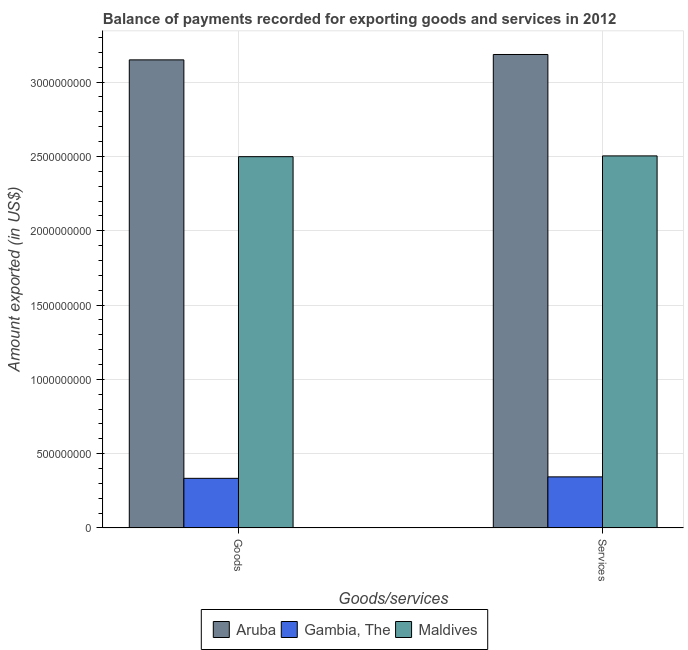How many groups of bars are there?
Ensure brevity in your answer.  2. Are the number of bars per tick equal to the number of legend labels?
Ensure brevity in your answer.  Yes. How many bars are there on the 2nd tick from the left?
Give a very brief answer. 3. How many bars are there on the 1st tick from the right?
Make the answer very short. 3. What is the label of the 1st group of bars from the left?
Provide a succinct answer. Goods. What is the amount of goods exported in Maldives?
Your response must be concise. 2.50e+09. Across all countries, what is the maximum amount of services exported?
Ensure brevity in your answer.  3.19e+09. Across all countries, what is the minimum amount of goods exported?
Your response must be concise. 3.34e+08. In which country was the amount of services exported maximum?
Give a very brief answer. Aruba. In which country was the amount of goods exported minimum?
Your response must be concise. Gambia, The. What is the total amount of goods exported in the graph?
Make the answer very short. 5.98e+09. What is the difference between the amount of goods exported in Maldives and that in Aruba?
Provide a succinct answer. -6.51e+08. What is the difference between the amount of services exported in Gambia, The and the amount of goods exported in Maldives?
Provide a succinct answer. -2.15e+09. What is the average amount of goods exported per country?
Your response must be concise. 1.99e+09. What is the difference between the amount of goods exported and amount of services exported in Aruba?
Provide a short and direct response. -3.61e+07. In how many countries, is the amount of services exported greater than 2400000000 US$?
Provide a succinct answer. 2. What is the ratio of the amount of goods exported in Aruba to that in Gambia, The?
Ensure brevity in your answer.  9.43. Is the amount of goods exported in Maldives less than that in Gambia, The?
Your response must be concise. No. In how many countries, is the amount of services exported greater than the average amount of services exported taken over all countries?
Make the answer very short. 2. What does the 1st bar from the left in Services represents?
Give a very brief answer. Aruba. What does the 2nd bar from the right in Services represents?
Your response must be concise. Gambia, The. How many bars are there?
Give a very brief answer. 6. What is the difference between two consecutive major ticks on the Y-axis?
Make the answer very short. 5.00e+08. Are the values on the major ticks of Y-axis written in scientific E-notation?
Your answer should be very brief. No. Does the graph contain any zero values?
Provide a short and direct response. No. How many legend labels are there?
Offer a very short reply. 3. What is the title of the graph?
Give a very brief answer. Balance of payments recorded for exporting goods and services in 2012. Does "Dominican Republic" appear as one of the legend labels in the graph?
Your answer should be very brief. No. What is the label or title of the X-axis?
Provide a short and direct response. Goods/services. What is the label or title of the Y-axis?
Your answer should be very brief. Amount exported (in US$). What is the Amount exported (in US$) in Aruba in Goods?
Give a very brief answer. 3.15e+09. What is the Amount exported (in US$) of Gambia, The in Goods?
Provide a succinct answer. 3.34e+08. What is the Amount exported (in US$) in Maldives in Goods?
Provide a succinct answer. 2.50e+09. What is the Amount exported (in US$) in Aruba in Services?
Offer a very short reply. 3.19e+09. What is the Amount exported (in US$) of Gambia, The in Services?
Make the answer very short. 3.44e+08. What is the Amount exported (in US$) in Maldives in Services?
Provide a succinct answer. 2.50e+09. Across all Goods/services, what is the maximum Amount exported (in US$) in Aruba?
Ensure brevity in your answer.  3.19e+09. Across all Goods/services, what is the maximum Amount exported (in US$) in Gambia, The?
Offer a terse response. 3.44e+08. Across all Goods/services, what is the maximum Amount exported (in US$) in Maldives?
Your response must be concise. 2.50e+09. Across all Goods/services, what is the minimum Amount exported (in US$) in Aruba?
Your response must be concise. 3.15e+09. Across all Goods/services, what is the minimum Amount exported (in US$) in Gambia, The?
Provide a succinct answer. 3.34e+08. Across all Goods/services, what is the minimum Amount exported (in US$) of Maldives?
Your response must be concise. 2.50e+09. What is the total Amount exported (in US$) in Aruba in the graph?
Your response must be concise. 6.34e+09. What is the total Amount exported (in US$) of Gambia, The in the graph?
Ensure brevity in your answer.  6.78e+08. What is the total Amount exported (in US$) in Maldives in the graph?
Offer a terse response. 5.00e+09. What is the difference between the Amount exported (in US$) of Aruba in Goods and that in Services?
Your response must be concise. -3.61e+07. What is the difference between the Amount exported (in US$) of Gambia, The in Goods and that in Services?
Your response must be concise. -9.83e+06. What is the difference between the Amount exported (in US$) in Maldives in Goods and that in Services?
Your answer should be compact. -5.20e+06. What is the difference between the Amount exported (in US$) in Aruba in Goods and the Amount exported (in US$) in Gambia, The in Services?
Your answer should be very brief. 2.81e+09. What is the difference between the Amount exported (in US$) of Aruba in Goods and the Amount exported (in US$) of Maldives in Services?
Provide a succinct answer. 6.46e+08. What is the difference between the Amount exported (in US$) in Gambia, The in Goods and the Amount exported (in US$) in Maldives in Services?
Give a very brief answer. -2.17e+09. What is the average Amount exported (in US$) in Aruba per Goods/services?
Keep it short and to the point. 3.17e+09. What is the average Amount exported (in US$) of Gambia, The per Goods/services?
Make the answer very short. 3.39e+08. What is the average Amount exported (in US$) in Maldives per Goods/services?
Offer a terse response. 2.50e+09. What is the difference between the Amount exported (in US$) of Aruba and Amount exported (in US$) of Gambia, The in Goods?
Your answer should be very brief. 2.82e+09. What is the difference between the Amount exported (in US$) of Aruba and Amount exported (in US$) of Maldives in Goods?
Provide a short and direct response. 6.51e+08. What is the difference between the Amount exported (in US$) of Gambia, The and Amount exported (in US$) of Maldives in Goods?
Provide a short and direct response. -2.16e+09. What is the difference between the Amount exported (in US$) of Aruba and Amount exported (in US$) of Gambia, The in Services?
Provide a short and direct response. 2.84e+09. What is the difference between the Amount exported (in US$) in Aruba and Amount exported (in US$) in Maldives in Services?
Provide a short and direct response. 6.82e+08. What is the difference between the Amount exported (in US$) of Gambia, The and Amount exported (in US$) of Maldives in Services?
Your answer should be very brief. -2.16e+09. What is the ratio of the Amount exported (in US$) in Aruba in Goods to that in Services?
Your answer should be very brief. 0.99. What is the ratio of the Amount exported (in US$) of Gambia, The in Goods to that in Services?
Your answer should be compact. 0.97. What is the ratio of the Amount exported (in US$) in Maldives in Goods to that in Services?
Your answer should be very brief. 1. What is the difference between the highest and the second highest Amount exported (in US$) in Aruba?
Offer a terse response. 3.61e+07. What is the difference between the highest and the second highest Amount exported (in US$) in Gambia, The?
Give a very brief answer. 9.83e+06. What is the difference between the highest and the second highest Amount exported (in US$) in Maldives?
Your answer should be compact. 5.20e+06. What is the difference between the highest and the lowest Amount exported (in US$) of Aruba?
Your answer should be compact. 3.61e+07. What is the difference between the highest and the lowest Amount exported (in US$) of Gambia, The?
Offer a very short reply. 9.83e+06. What is the difference between the highest and the lowest Amount exported (in US$) in Maldives?
Your answer should be very brief. 5.20e+06. 